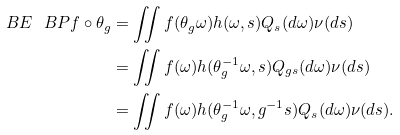<formula> <loc_0><loc_0><loc_500><loc_500>\ B E _ { \ } B P f \circ \theta _ { g } & = \iint f ( \theta _ { g } \omega ) h ( \omega , s ) Q _ { s } ( d \omega ) \nu ( d s ) \\ & = \iint f ( \omega ) h ( \theta _ { g } ^ { - 1 } \omega , s ) Q _ { g s } ( d \omega ) \nu ( d s ) \\ & = \iint f ( \omega ) h ( \theta _ { g } ^ { - 1 } \omega , g ^ { - 1 } s ) Q _ { s } ( d \omega ) \nu ( d s ) .</formula> 